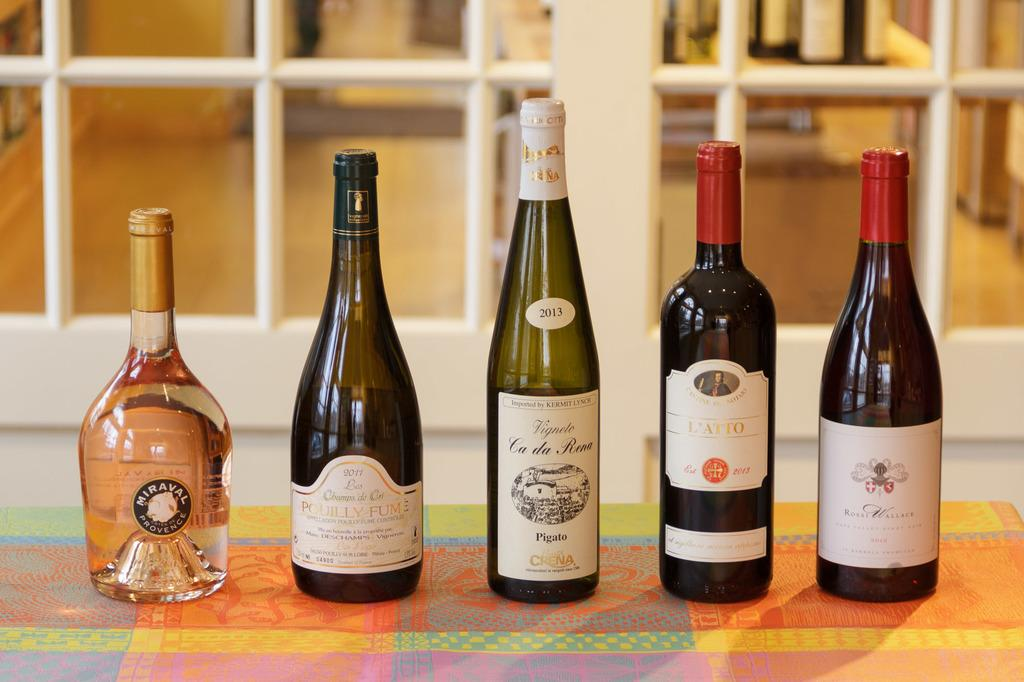<image>
Share a concise interpretation of the image provided. the word Pigato that is on a wine bottle 